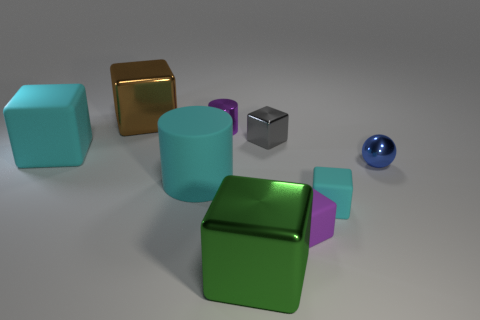Are there more large objects than blue objects?
Your response must be concise. Yes. There is a cyan matte thing that is both on the left side of the big green metal object and in front of the small blue metal object; what is its size?
Keep it short and to the point. Large. There is a large cube that is the same color as the rubber cylinder; what is it made of?
Your answer should be very brief. Rubber. Are there the same number of tiny shiny cylinders in front of the purple metal thing and large green rubber things?
Keep it short and to the point. Yes. Does the green block have the same size as the gray metal thing?
Give a very brief answer. No. What is the color of the object that is both to the left of the small purple cylinder and behind the tiny gray cube?
Your answer should be compact. Brown. What material is the tiny purple thing behind the cyan rubber block on the right side of the tiny gray metal block made of?
Your answer should be compact. Metal. There is a purple object that is the same shape as the tiny cyan rubber object; what is its size?
Provide a short and direct response. Small. Is the color of the metal cube that is behind the purple cylinder the same as the large matte block?
Keep it short and to the point. No. Is the number of large matte cylinders less than the number of large cyan things?
Your answer should be very brief. Yes. 